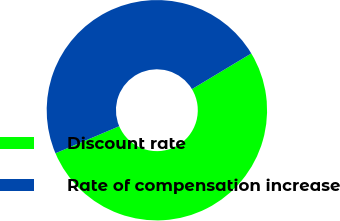Convert chart to OTSL. <chart><loc_0><loc_0><loc_500><loc_500><pie_chart><fcel>Discount rate<fcel>Rate of compensation increase<nl><fcel>52.23%<fcel>47.77%<nl></chart> 